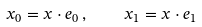<formula> <loc_0><loc_0><loc_500><loc_500>x _ { 0 } = x \cdot e _ { 0 } \, , \quad x _ { 1 } = x \cdot e _ { 1 }</formula> 